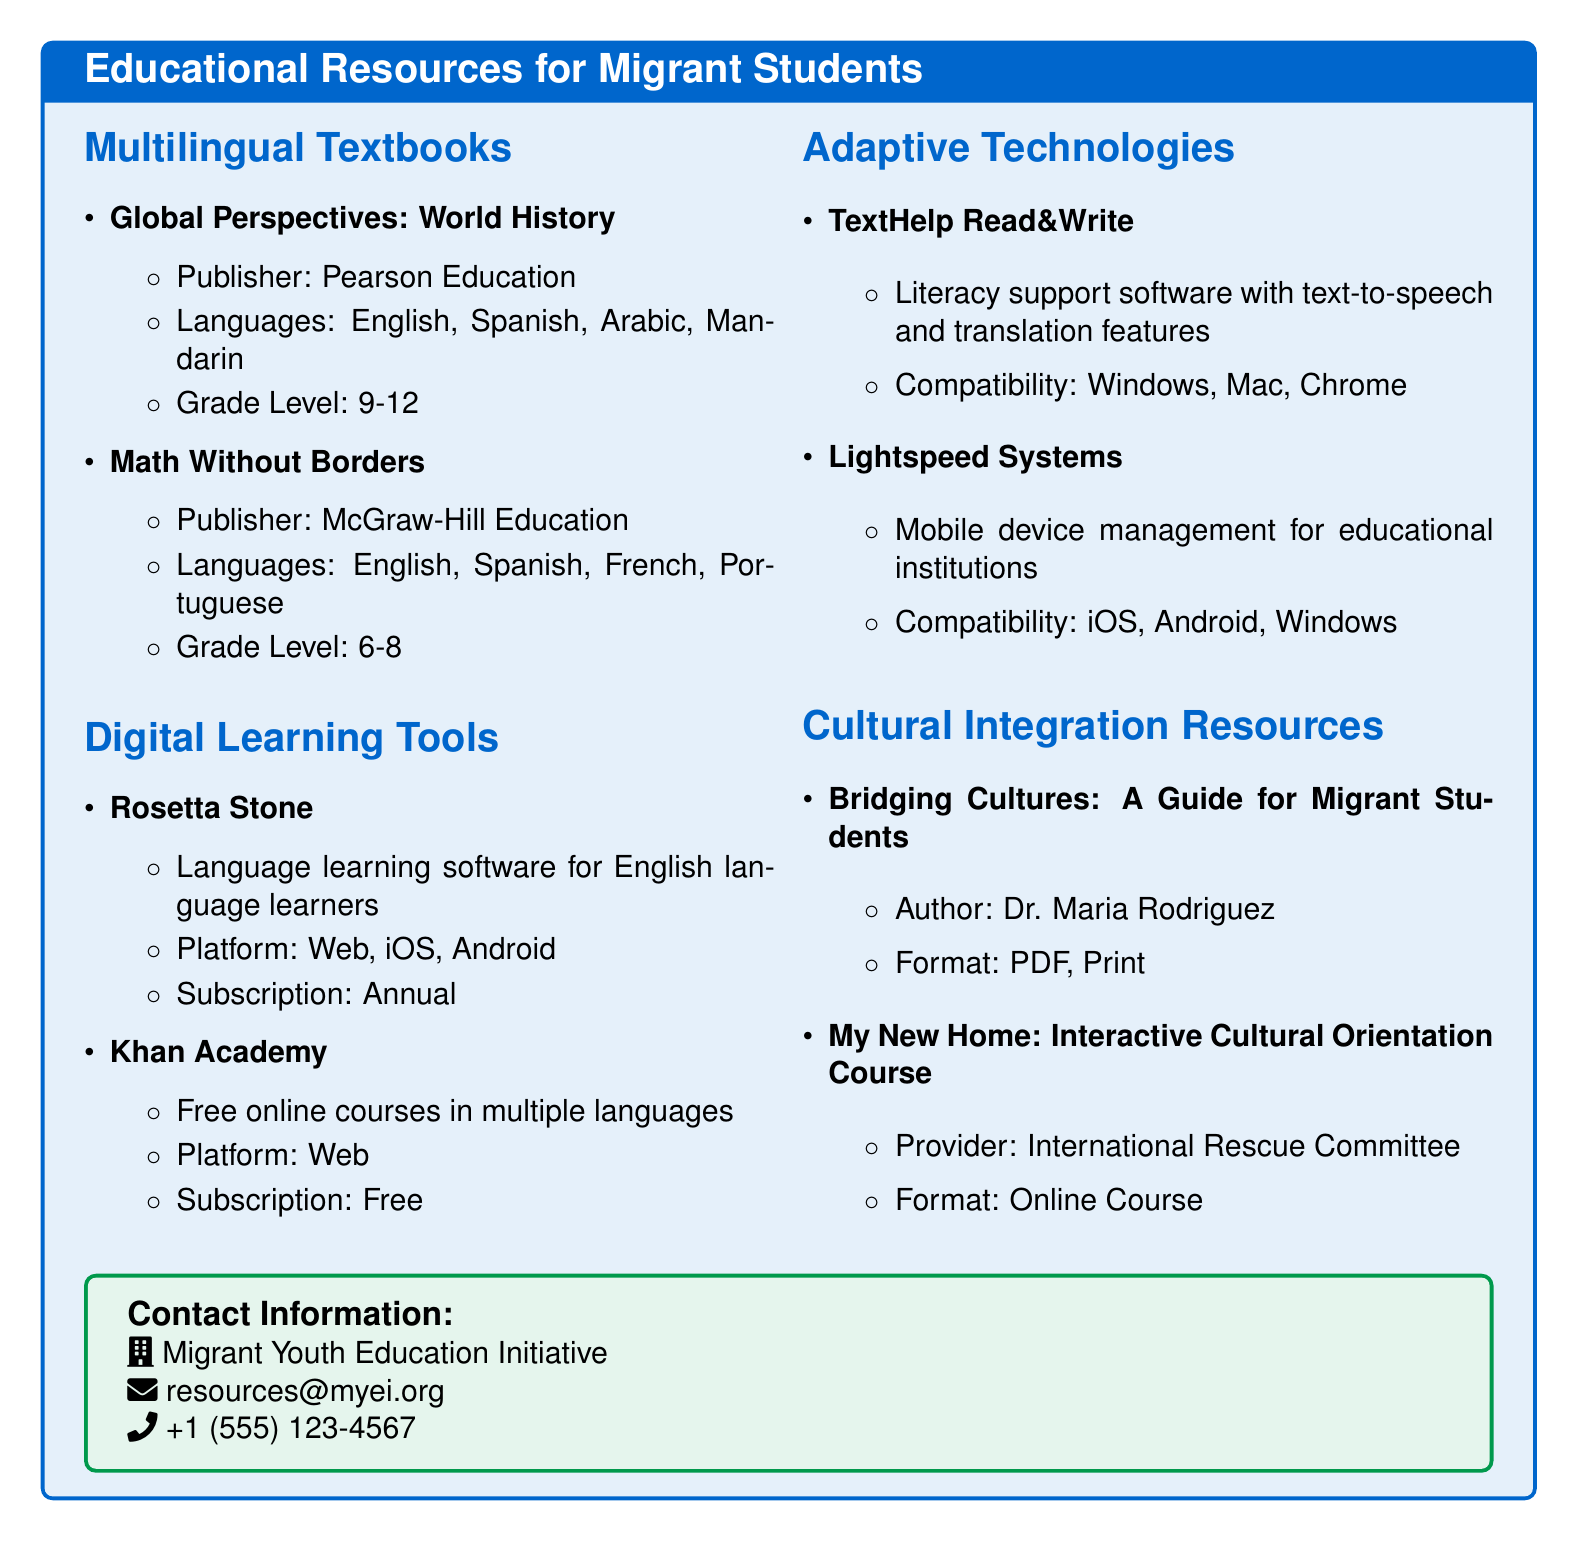What is the title of the educational resources catalog? The title of the catalog is the first thing presented in the document, which is "Educational Resources for Migrant Students."
Answer: Educational Resources for Migrant Students Who is the author of "Bridging Cultures: A Guide for Migrant Students"? The author's name is listed in the section for cultural integration resources as "Dr. Maria Rodriguez."
Answer: Dr. Maria Rodriguez What languages are available for the textbook "Global Perspectives: World History"? The languages are specified in the item for the textbook, which are "English, Spanish, Arabic, Mandarin."
Answer: English, Spanish, Arabic, Mandarin Which organization provides the "My New Home: Interactive Cultural Orientation Course"? The provider's name is listed with the course details, which is "International Rescue Committee."
Answer: International Rescue Committee How many grade levels does "Math Without Borders" target? The grade level for "Math Without Borders" is provided, indicating it targets grades "6-8," which represents three grade levels.
Answer: 6-8 What type of platform does "Khan Academy" operate on? The platform for "Khan Academy" is specified in the document, stating it is available on "Web."
Answer: Web Which adaptive technology is compatible with both Windows and Mac? The compatibility details for TextHelp Read&Write indicate it works with both "Windows" and "Mac."
Answer: Windows, Mac What kind of subscription does "Rosetta Stone" involve? The subscription details are given, specifying that it is an "Annual" subscription.
Answer: Annual 